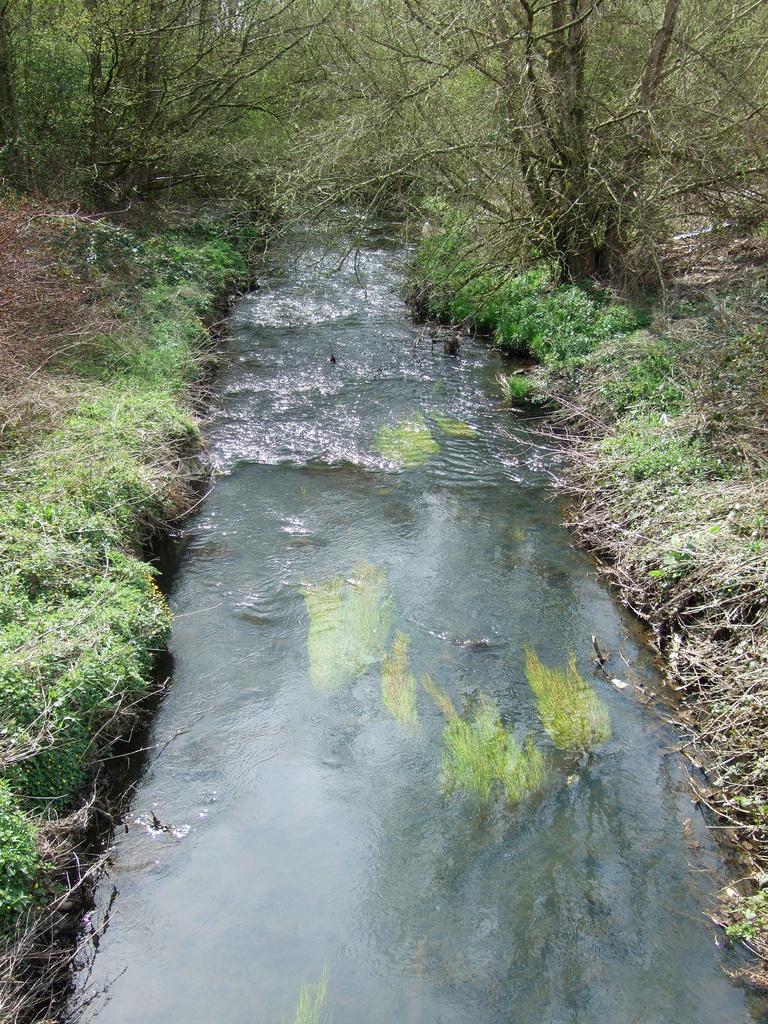Could you give a brief overview of what you see in this image? In the image there is a canal in the middle with plant and grass on either side of it on the land. 